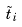Convert formula to latex. <formula><loc_0><loc_0><loc_500><loc_500>\tilde { t } _ { i }</formula> 